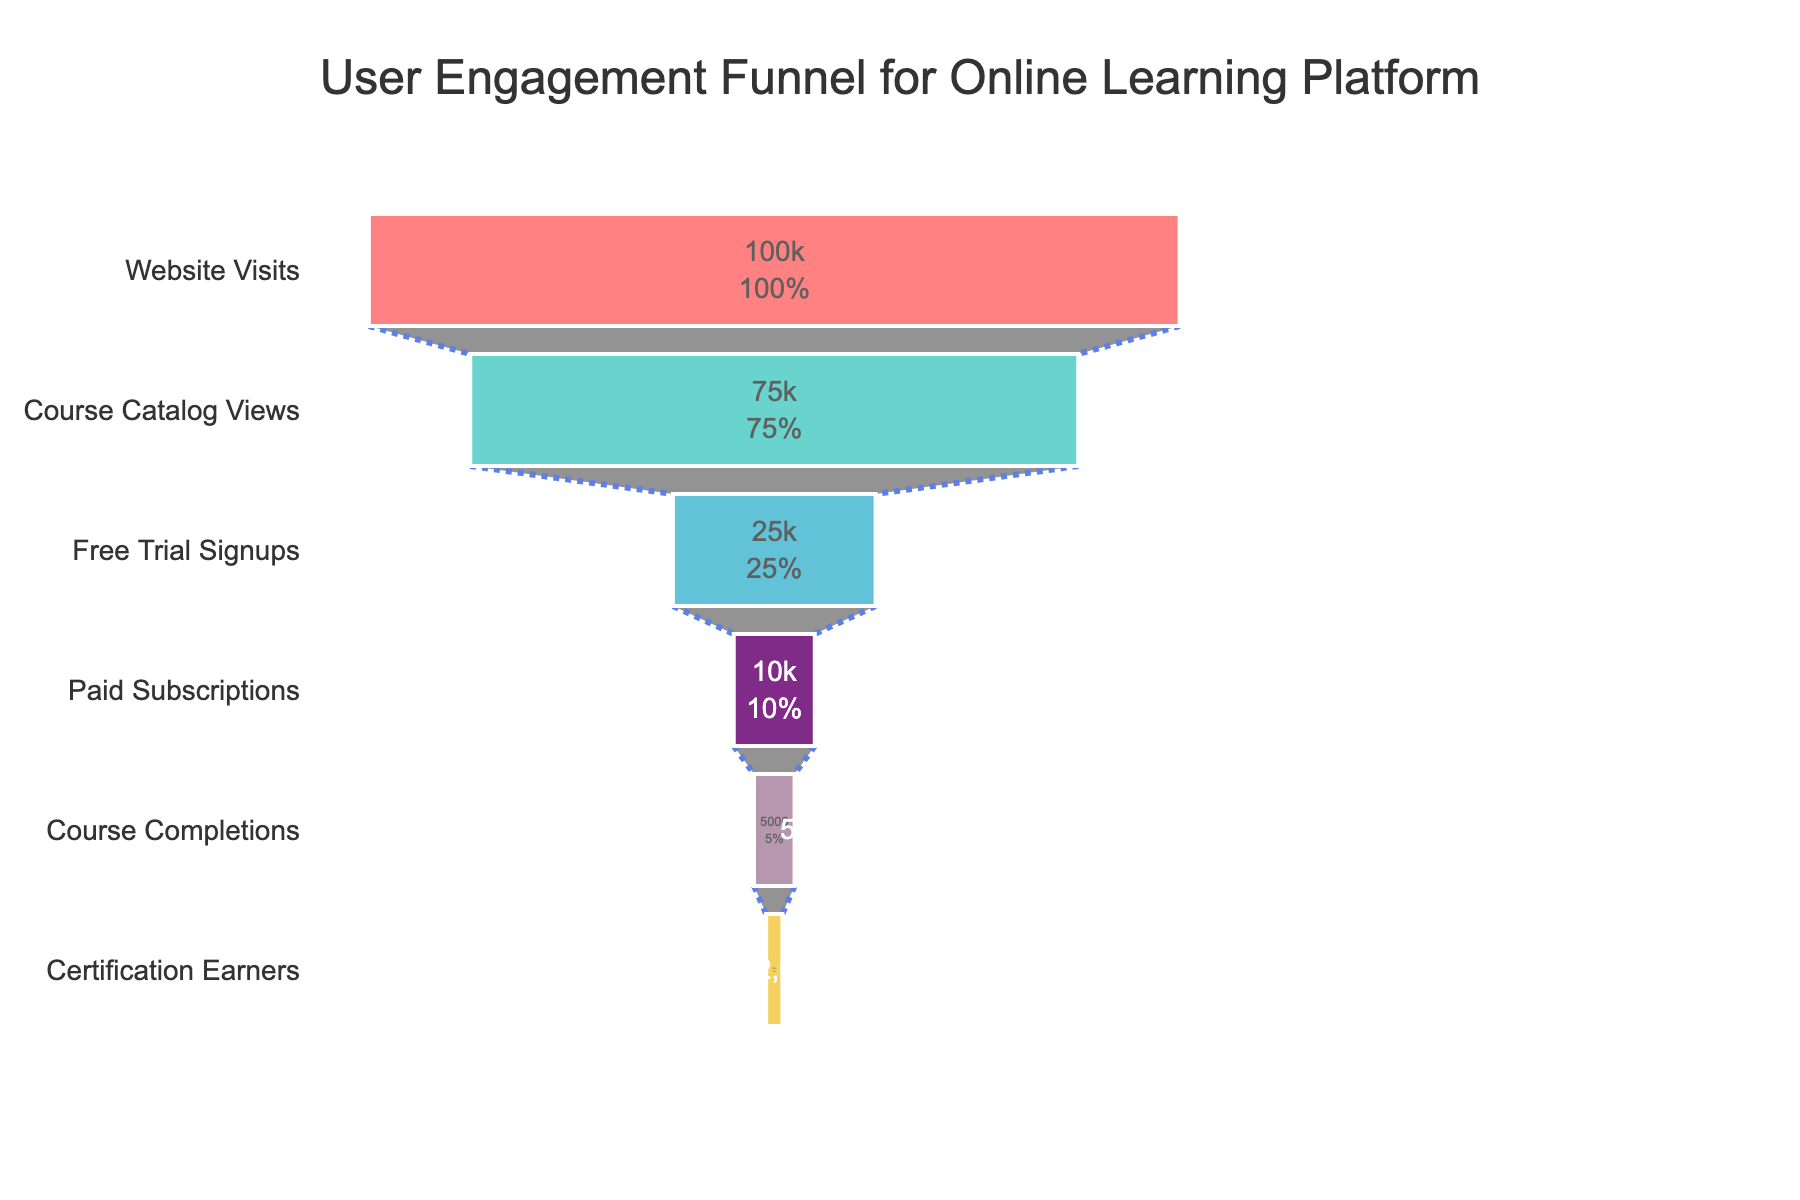What is the total number of website visits? The total number of website visits is represented by the first stage in the funnel chart. According to the data, there are 100,000 website visits.
Answer: 100,000 How many users completed the courses? The number of users who completed the courses is shown in the "Course Completions" stage in the funnel chart. According to the data, 5,000 users completed the courses.
Answer: 5,000 What percentage of users who visited the website ended up earning certifications? To find the percentage, divide the number of users who earned certifications by the total number of website visits, then multiply by 100. So, (2,000 / 100,000) * 100 = 2%.
Answer: 2% Which stage in the funnel shows the sharpest drop in user numbers? The sharpest drop can be assessed by observing the difference between consecutive stages. The largest difference is from "Course Catalog Views" to "Free Trial Signups", which drops from 75,000 to 25,000 users, a difference of 50,000.
Answer: From Course Catalog Views to Free Trial Signups How many more users signed up for a free trial than those who eventually got paid subscriptions? Subtract the number of paid subscriptions from free trial signups: 25,000 - 10,000 = 15,000.
Answer: 15,000 What is the conversion rate from free trial signups to paid subscriptions? The conversion rate is calculated by dividing the number of paid subscriptions by the number of free trial signups, then multiplying by 100. So, (10,000 / 25,000) * 100 = 40%.
Answer: 40% What is the percentage drop from "Paid Subscriptions" to "Course Completions"? To find the percentage drop, calculate the difference between the two stages, divide by the number in the "Paid Subscriptions" stage, and then multiply by 100. So, ((10,000 - 5,000) / 10,000) * 100 = 50%.
Answer: 50% On average, how many users are there per stage? To find the average, sum all the user numbers across the stages, then divide by the number of stages. (100,000 + 75,000 + 25,000 + 10,000 + 5,000 + 2,000) / 6 = 35,333.33.
Answer: 35,333.33 